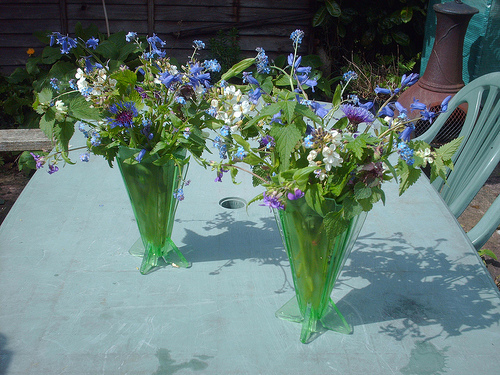Please provide the bounding box coordinate of the region this sentence describes: A piece of wood. The specified coordinates seem to encompass the edge of a wooden table's surface, revealing its textured grain and natural brown hues. 